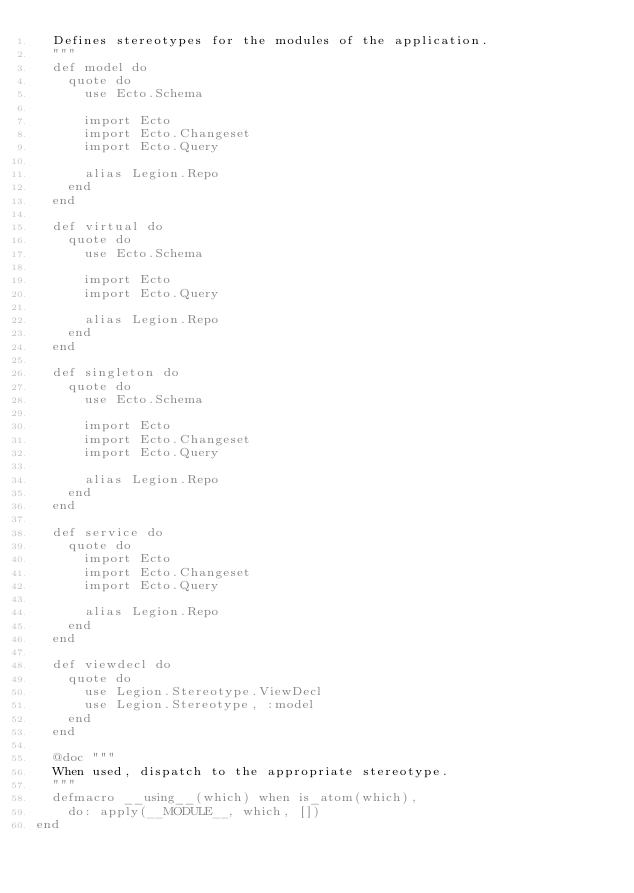Convert code to text. <code><loc_0><loc_0><loc_500><loc_500><_Elixir_>  Defines stereotypes for the modules of the application.
  """
  def model do
    quote do
      use Ecto.Schema

      import Ecto
      import Ecto.Changeset
      import Ecto.Query

      alias Legion.Repo
    end
  end

  def virtual do
    quote do
      use Ecto.Schema

      import Ecto
      import Ecto.Query

      alias Legion.Repo
    end
  end

  def singleton do
    quote do
      use Ecto.Schema

      import Ecto
      import Ecto.Changeset
      import Ecto.Query

      alias Legion.Repo
    end
  end

  def service do
    quote do
      import Ecto
      import Ecto.Changeset
      import Ecto.Query

      alias Legion.Repo
    end
  end

  def viewdecl do
    quote do
      use Legion.Stereotype.ViewDecl
      use Legion.Stereotype, :model
    end
  end

  @doc """
  When used, dispatch to the appropriate stereotype.
  """
  defmacro __using__(which) when is_atom(which),
    do: apply(__MODULE__, which, [])
end
</code> 